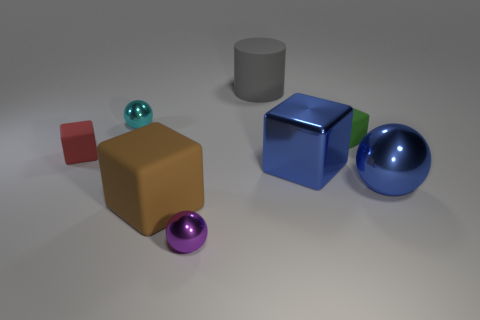Is there another shiny thing of the same shape as the cyan thing?
Offer a terse response. Yes. What is the shape of the gray rubber thing that is the same size as the brown rubber block?
Your answer should be very brief. Cylinder. Are there any small blocks behind the rubber block behind the tiny thing that is left of the cyan metal ball?
Your answer should be very brief. No. Are there any other gray matte cylinders that have the same size as the gray cylinder?
Your response must be concise. No. What size is the red object that is in front of the green block?
Your answer should be very brief. Small. The matte thing that is on the left side of the cyan thing that is to the left of the big metal thing that is behind the blue ball is what color?
Keep it short and to the point. Red. What is the color of the tiny ball that is right of the small sphere behind the red object?
Your response must be concise. Purple. Is the number of purple shiny objects that are in front of the cyan ball greater than the number of big brown matte objects that are behind the gray matte cylinder?
Give a very brief answer. Yes. Is the material of the tiny thing on the left side of the cyan metal ball the same as the large thing behind the green cube?
Your answer should be compact. Yes. There is a big cylinder; are there any cubes on the right side of it?
Your response must be concise. Yes. 